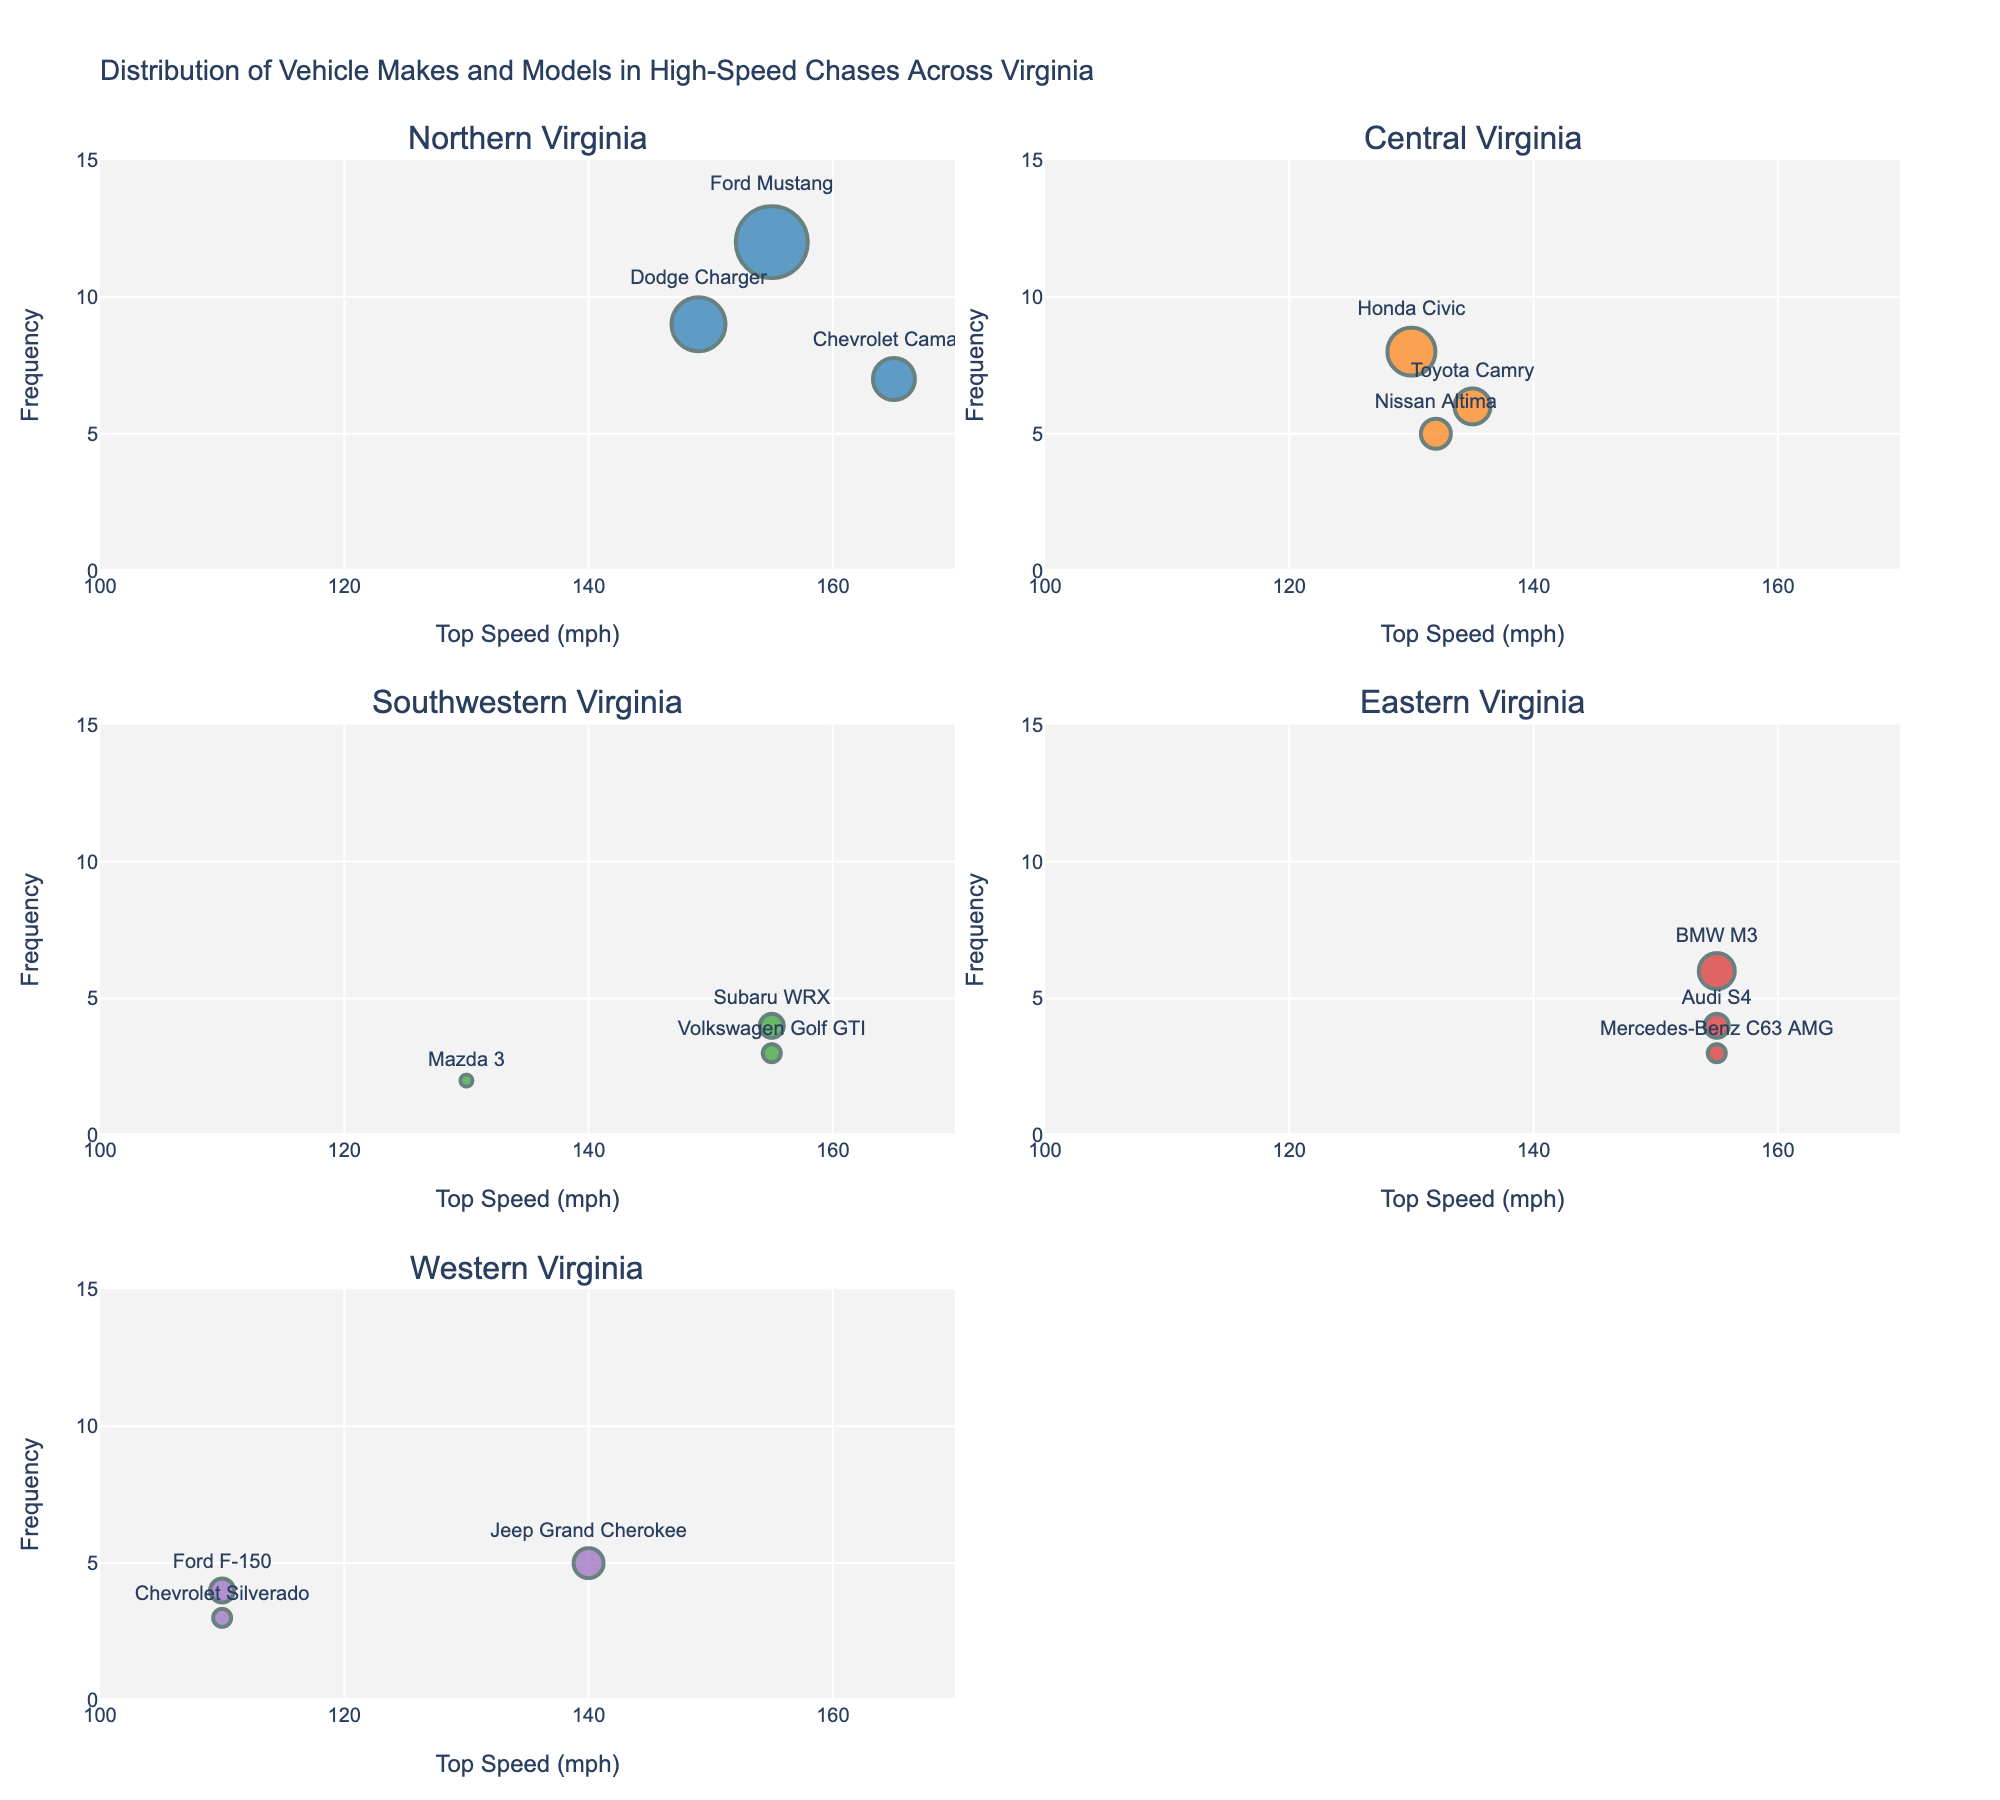what is the most frequent vehicle make and model involved in high-speed chases in Northern Virginia? The scatter plot for Northern Virginia shows that the Ford Mustang has the highest frequency with a count of 12.
Answer: Ford Mustang Which region features a vehicle with the highest top speed, and what is that top speed? The scatter plot for Northern Virginia has a Chevrolet Camaro with a top speed of 165 mph, which is the highest among all regions.
Answer: Northern Virginia, 165 mph How many regions have vehicles with a top speed of exactly 155 mph? The scatter plots for Northern Virginia, Southwestern Virginia, and Eastern Virginia show vehicles with top speeds of exactly 155 mph.
Answer: Three regions In Central Virginia, what is the combined frequency of vehicles with top speeds above 130 mph? The scatter plot for Central Virginia shows three vehicles: Honda Civic (8), Toyota Camry (6), and Nissan Altima (5), all above 130 mph. Their combined frequency is 8 + 6 + 5 = 19.
Answer: 19 Which vehicle make and model in Western Virginia has the highest frequency, and what is that frequency? The scatter plot for Western Virginia shows that the Jeep Grand Cherokee has the highest frequency with a count of 5.
Answer: Jeep Grand Cherokee, 5 Compare the frequency of vehicles in high-speed chases in Eastern Virginia to those in Northern Virginia. Which region has a higher frequency? Summing the individual frequencies for all vehicles in each region: Eastern Virginia has 6 (BMW M3) + 4 (Audi S4) + 3 (Mercedes-Benz C63 AMG) = 13; Northern Virginia has 12 (Ford Mustang) + 9 (Dodge Charger) + 7 (Chevrolet Camaro) = 28. Northern Virginia has a higher frequency.
Answer: Northern Virginia What is the average top speed of the vehicles involved in high-speed chases in Southwestern Virginia? The scatter plot for Southwestern Virginia shows top speeds of Subaru WRX (155), Volkswagen Golf GTI (155), and Mazda 3 (130). The average top speed is (155 + 155 + 130) / 3 = 146.67 mph.
Answer: 146.67 mph In which region is the Ford Mustang involved in high-speed chases, and what is its frequency? The scatter plot for Northern Virginia shows the Ford Mustang with a frequency of 12.
Answer: Northern Virginia, 12 What is the range of the top speeds for the vehicles in Central Virginia? The scatter plot for Central Virginia shows top speeds of Honda Civic (130), Toyota Camry (135), and Nissan Altima (132). The range is 135 - 130 = 5 mph.
Answer: 5 mph How does the frequency of the Mercedes-Benz C63 AMG in Eastern Virginia compare to the Subaru WRX in Southwestern Virginia? The scatter plot shows that the frequency of the Mercedes-Benz C63 AMG is 3 in Eastern Virginia, and the frequency of the Subaru WRX is 4 in Southwestern Virginia. The Subaru WRX has a higher frequency.
Answer: Subaru WRX is higher 